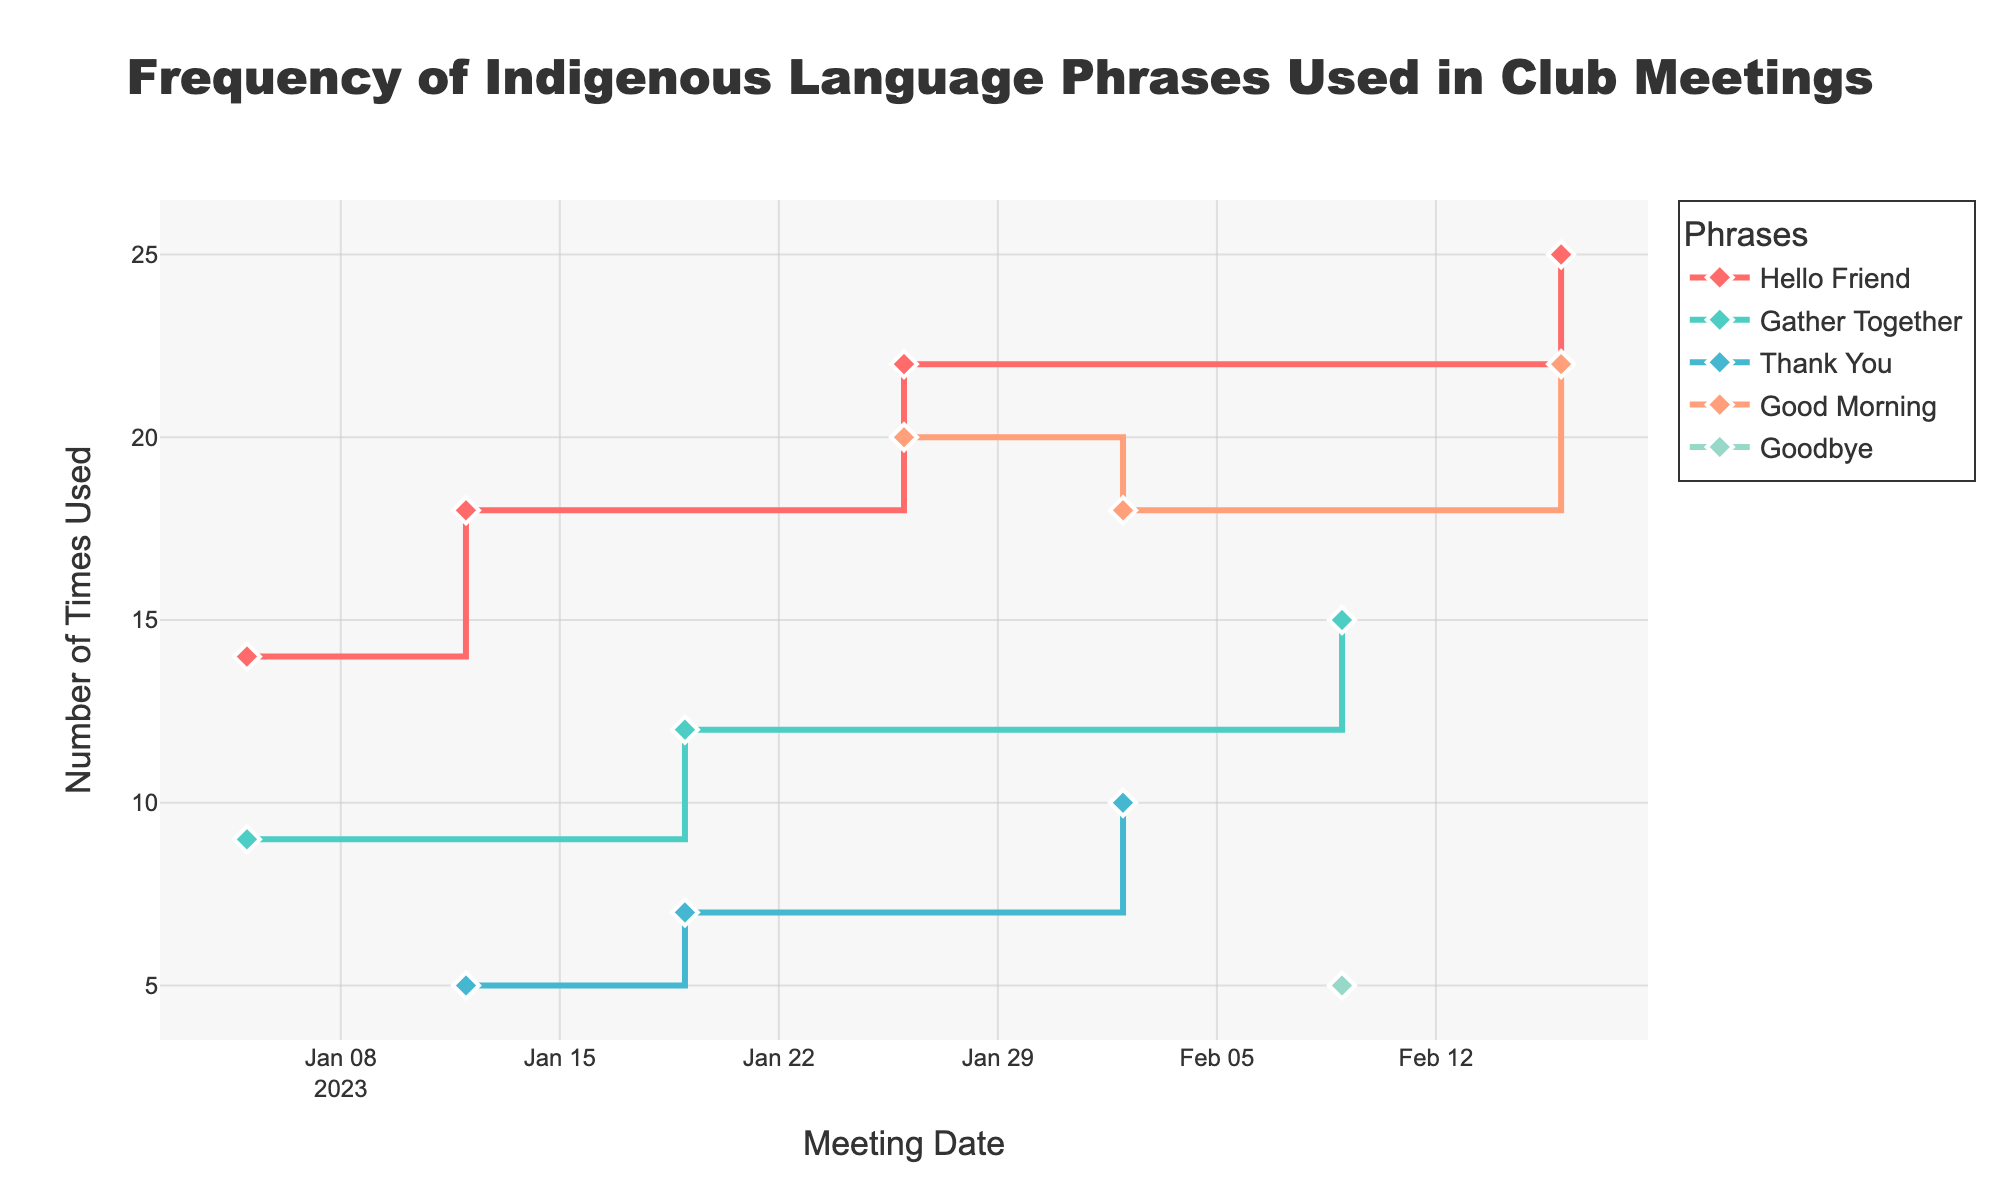what is the title of the figure? The title of the figure is located at the top and is usually the largest text. The title provides a summary of what the figure is about.
Answer: Frequency of Indigenous Language Phrases Used in Club Meetings how many different phrases are shown in the plot? Each line in the plot represents a different phrase, and they are distinguishable by their colors and legends.
Answer: 5 what's the phrase used most frequently in a single meeting? To find the phrase used most frequently in a single meeting, look for the highest point on the y-axis and check the corresponding phrase in the legend.
Answer: Good Morning (on 2023-01-26 with 20 times) on which date was the phrase "thank you" used the most? Look at the line corresponding to the "Thank You" phrase on the plot and identify the highest point along the x-axis.
Answer: February 2, 2023 how did the usage of "gather together" change over time? Follow the line for the "Gather Together" phrase from left to right along the x-axis to observe the changes in the y-values.
Answer: It increased from 9 on January 5, 2023, to 15 on February 9, 2023 compare the usage of "hello friend" and "thank you" on January 12, 2023. Which was used more? Find the points for "Hello Friend" and "Thank You" on the date January 12, 2023, and compare their y-values.
Answer: Hello Friend what's the cumulative count of "good morning" phrases used? Add the y-values for each point representing "Good Morning" across all dates.
Answer: 20 + 18 + 22 = 60 which phrase showed the most consistent usage over time? Identify the phrase whose line remains relatively flat or shows the least fluctuation over the time period.
Answer: Good Morning what was the total usage of phrases on January 26, 2023? Sum the y-values of all phrases on the date January 26, 2023.
Answer: 20 (Good Morning) + 22 (Hello Friend) = 42 which phrase had the most significant increase in usage from one meeting to the next? Look for the phrase with the largest positive jump in y-values between two consecutive dates.
Answer: Hello Friend (from January 5, 2023 to January 12, 2023) 